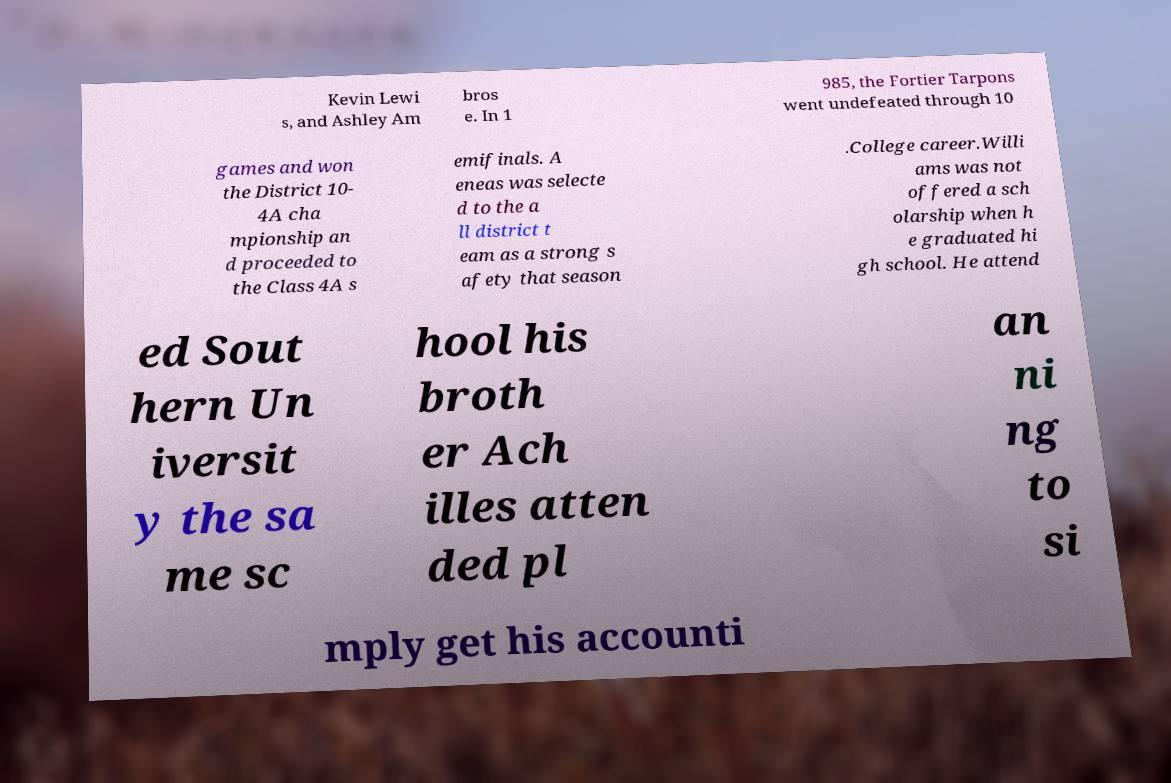Could you extract and type out the text from this image? Kevin Lewi s, and Ashley Am bros e. In 1 985, the Fortier Tarpons went undefeated through 10 games and won the District 10- 4A cha mpionship an d proceeded to the Class 4A s emifinals. A eneas was selecte d to the a ll district t eam as a strong s afety that season .College career.Willi ams was not offered a sch olarship when h e graduated hi gh school. He attend ed Sout hern Un iversit y the sa me sc hool his broth er Ach illes atten ded pl an ni ng to si mply get his accounti 